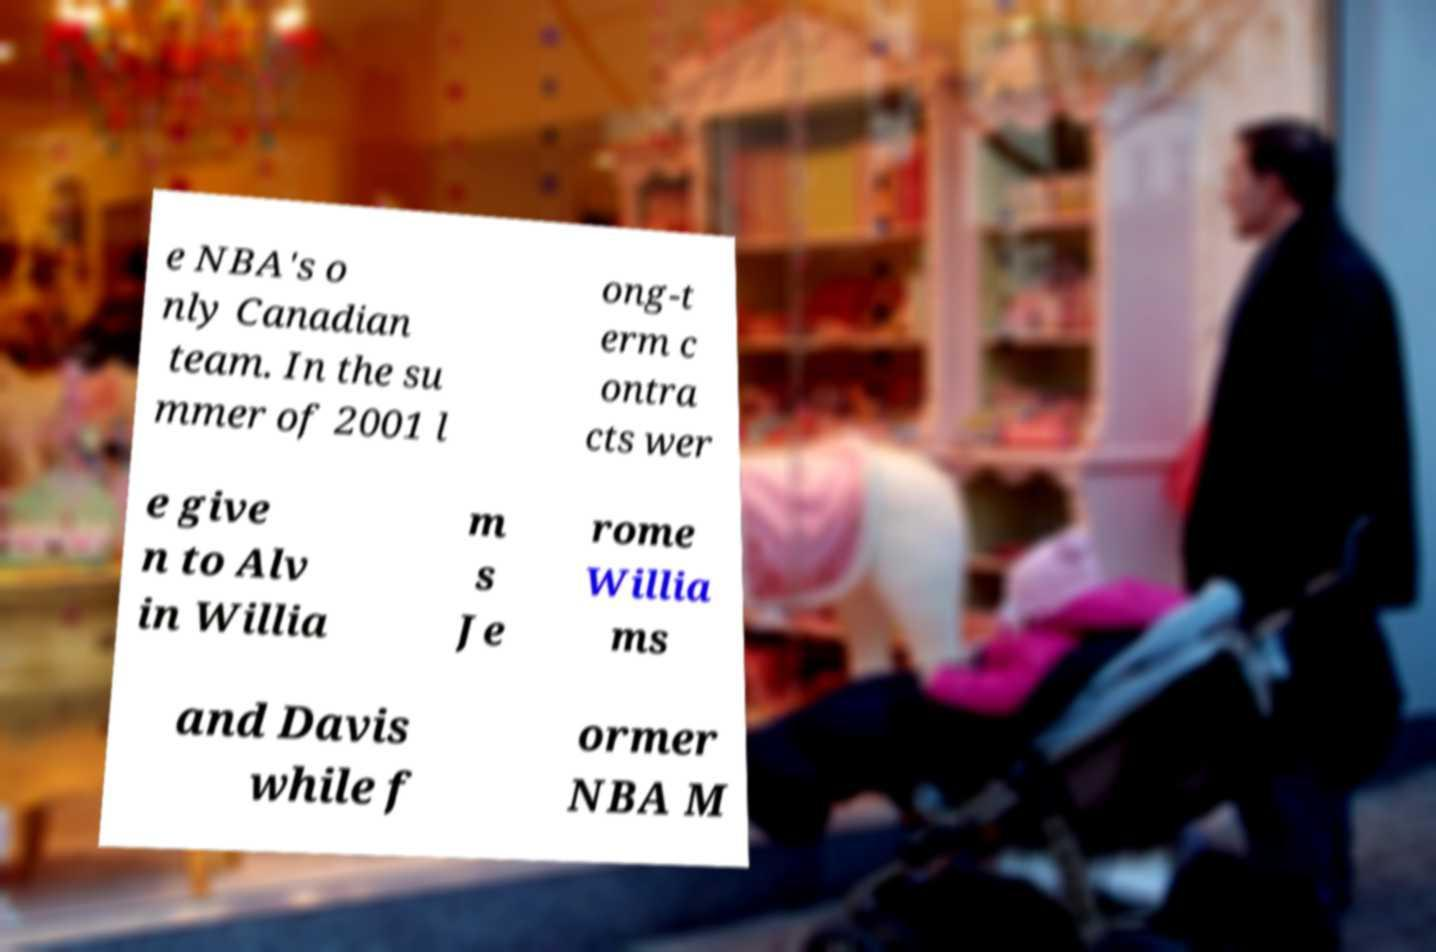Could you assist in decoding the text presented in this image and type it out clearly? e NBA's o nly Canadian team. In the su mmer of 2001 l ong-t erm c ontra cts wer e give n to Alv in Willia m s Je rome Willia ms and Davis while f ormer NBA M 